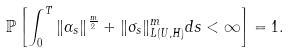Convert formula to latex. <formula><loc_0><loc_0><loc_500><loc_500>\mathbb { P } \left [ \int _ { 0 } ^ { T } \| \alpha _ { s } \| ^ { \frac { m } { 2 } } + \| \sigma _ { s } \| _ { L ( U , H ) } ^ { m } d s < \infty \right ] = 1 .</formula> 